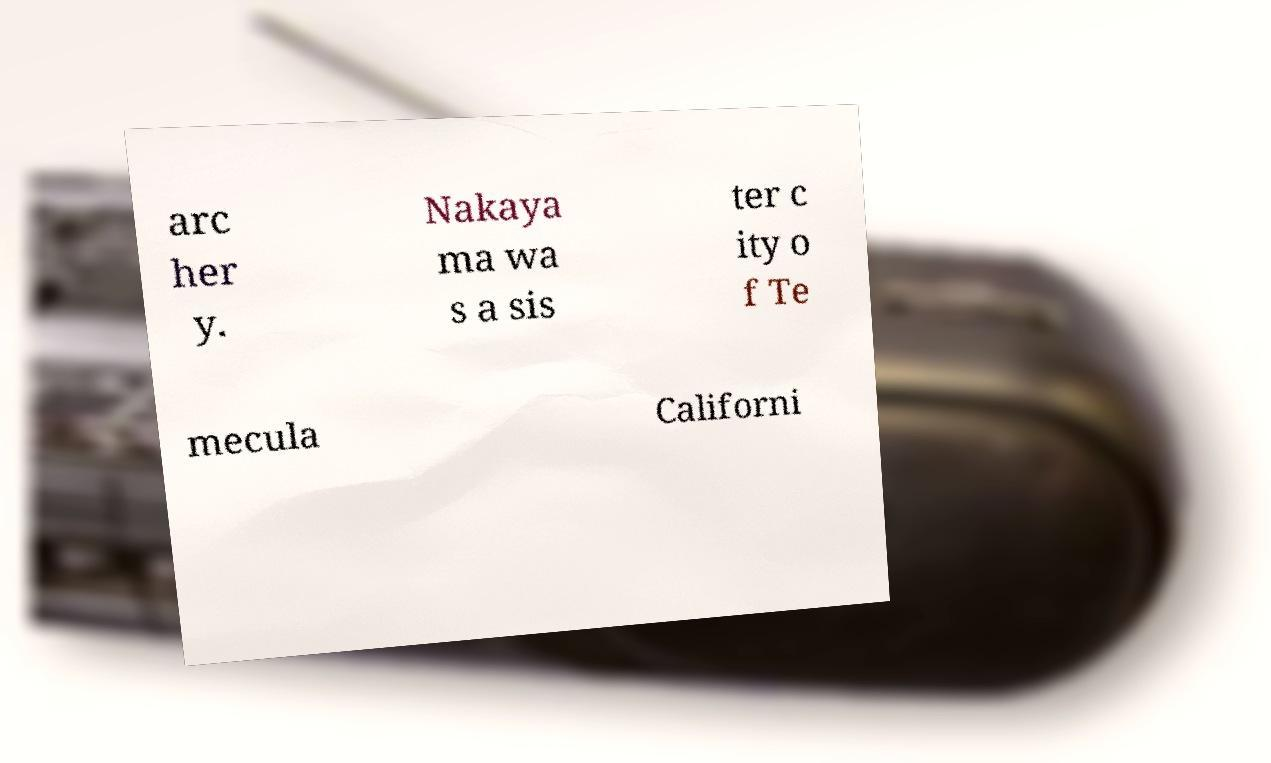Can you accurately transcribe the text from the provided image for me? arc her y. Nakaya ma wa s a sis ter c ity o f Te mecula Californi 